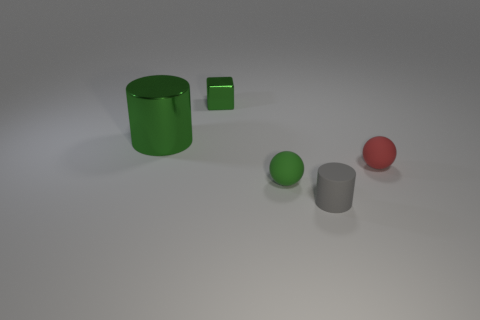The cylinder that is in front of the green object that is in front of the tiny red object is what color?
Provide a succinct answer. Gray. There is a tiny gray thing; is it the same shape as the green shiny thing behind the green cylinder?
Keep it short and to the point. No. What number of matte balls are the same size as the gray thing?
Ensure brevity in your answer.  2. What material is the tiny gray thing that is the same shape as the large metallic object?
Offer a very short reply. Rubber. Do the small matte thing on the right side of the gray thing and the shiny thing in front of the tiny block have the same color?
Provide a succinct answer. No. There is a tiny object behind the red sphere; what is its shape?
Offer a terse response. Cube. The metal cylinder has what color?
Make the answer very short. Green. There is a green object that is made of the same material as the red ball; what shape is it?
Offer a terse response. Sphere. There is a cylinder that is to the right of the green shiny cube; does it have the same size as the metallic cube?
Offer a very short reply. Yes. What number of things are cylinders that are behind the small green matte sphere or small matte objects in front of the red sphere?
Your answer should be very brief. 3. 